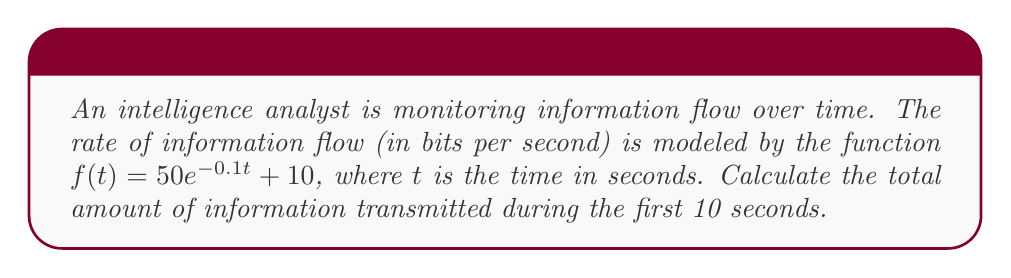What is the answer to this math problem? To solve this problem, we need to calculate the area under the curve of $f(t)$ from $t=0$ to $t=10$. This can be done using a definite integral.

1) Set up the integral:
   $$\int_0^{10} (50e^{-0.1t} + 10) dt$$

2) Split the integral:
   $$\int_0^{10} 50e^{-0.1t} dt + \int_0^{10} 10 dt$$

3) Solve the first part:
   $$50 \int_0^{10} e^{-0.1t} dt = -500 [e^{-0.1t}]_0^{10}$$
   $$= -500 (e^{-1} - 1) = 500(1 - e^{-1})$$

4) Solve the second part:
   $$10 \int_0^{10} dt = 10t|_0^{10} = 100$$

5) Add the results:
   $$500(1 - e^{-1}) + 100 = 500 - 500e^{-1} + 100 = 600 - 500e^{-1}$$

6) Calculate the final value:
   $$600 - 500e^{-1} \approx 415.9$$

The total amount of information transmitted is approximately 415.9 bits.
Answer: 415.9 bits 